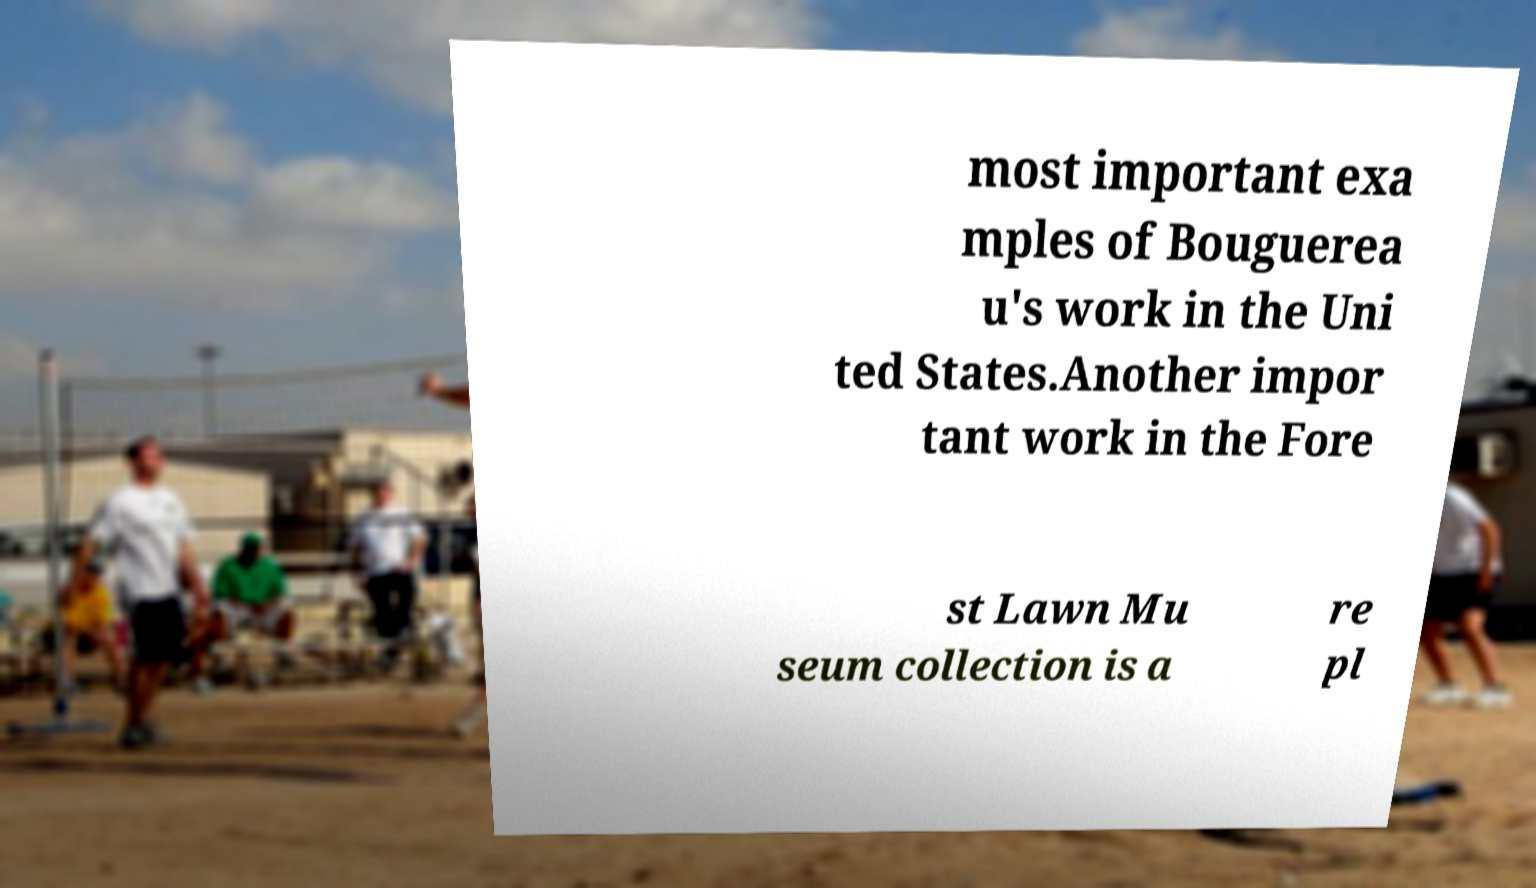For documentation purposes, I need the text within this image transcribed. Could you provide that? most important exa mples of Bouguerea u's work in the Uni ted States.Another impor tant work in the Fore st Lawn Mu seum collection is a re pl 